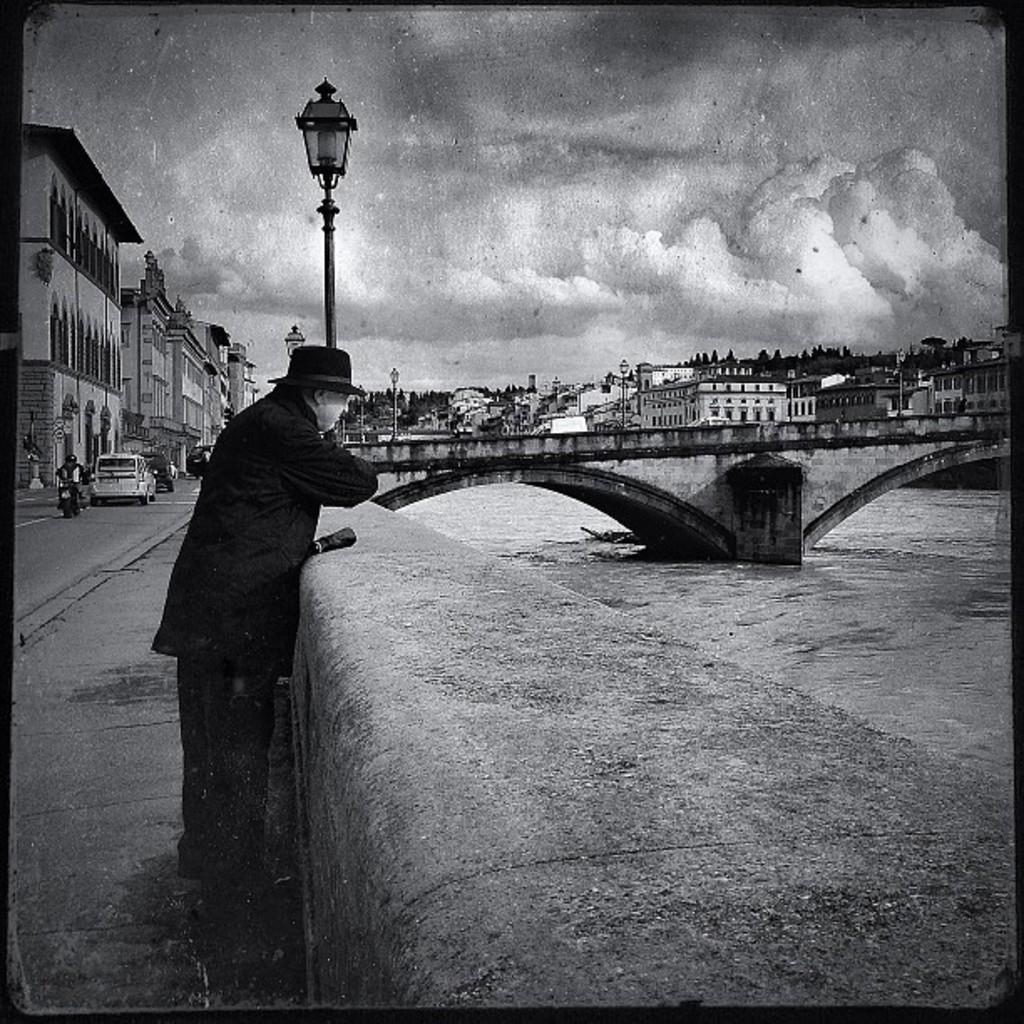Please provide a concise description of this image. This is a black and white image and here we can see a person wearing hat and standing. In the background, there are vehicles on the road, we can see a bridge, poles, buildings and we can see some lights. At the bottom, there is water and at the top, there are clouds in the sky. 